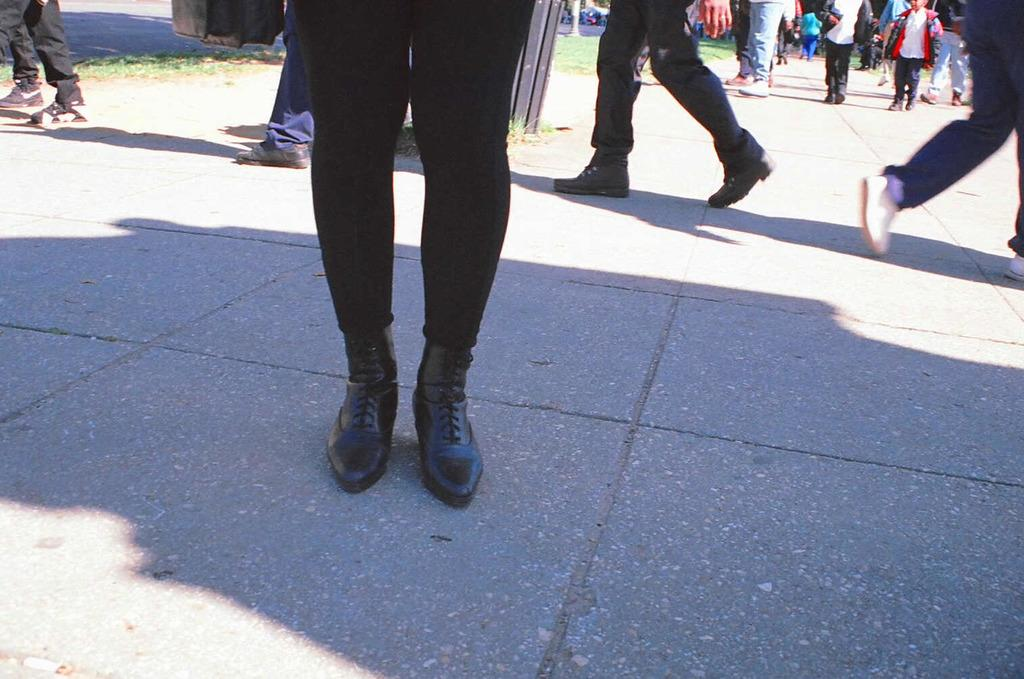What are the people in the image doing? The people in the image are walking. Can you describe the appearance of the kid in the image? The kid is visible in the image and is wearing a red color sweater. How many rings does the kid have on their arm in the image? There is no mention of rings or any specific body part in the image, so it cannot be determined. 